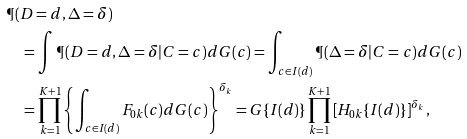Convert formula to latex. <formula><loc_0><loc_0><loc_500><loc_500>& \P ( D = d , \Delta = \delta ) \\ & \quad = \int \P ( D = d , \Delta = \delta | C = c ) d G ( c ) = \int _ { c \in I ( d ) } \P ( \Delta = \delta | C = c ) d G ( c ) \\ & \quad = \prod _ { k = 1 } ^ { K + 1 } \left \{ \int _ { c \in I ( d ) } F _ { 0 k } ( c ) d G ( c ) \right \} ^ { \delta _ { k } } = G \{ I ( d ) \} \prod _ { k = 1 } ^ { K + 1 } \left [ H _ { 0 k } \{ I ( d ) \} \right ] ^ { \delta _ { k } } ,</formula> 